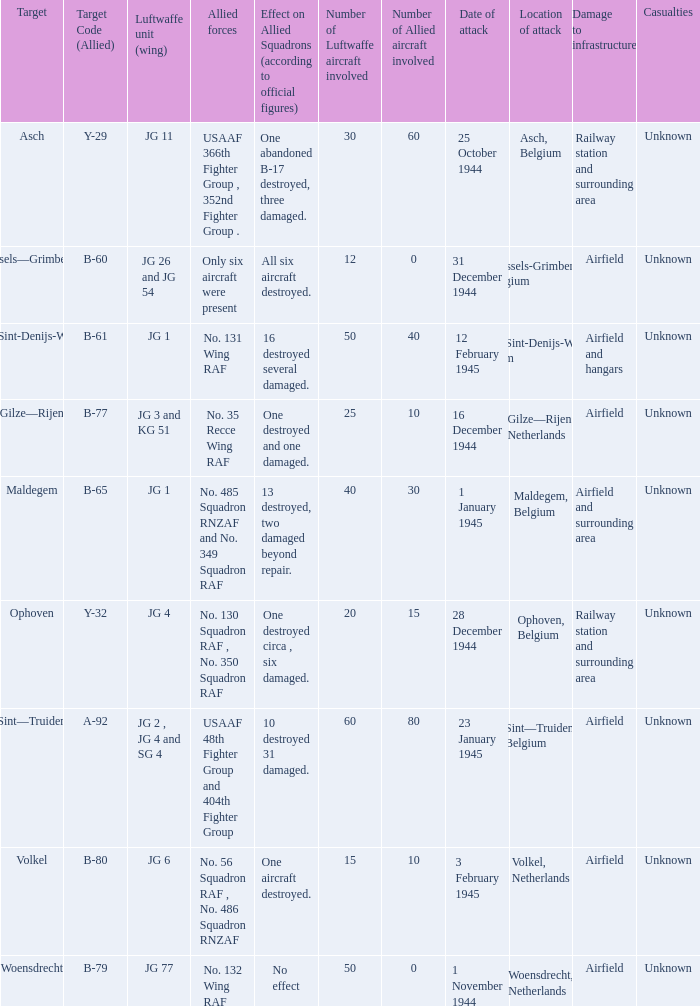Which Allied Force targetted Woensdrecht? No. 132 Wing RAF. 